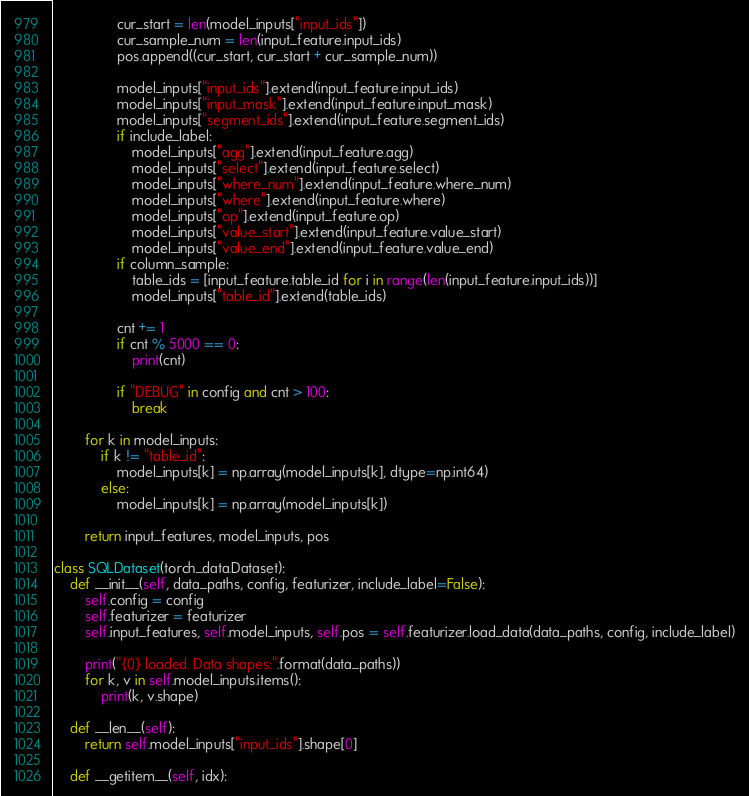Convert code to text. <code><loc_0><loc_0><loc_500><loc_500><_Python_>
                cur_start = len(model_inputs["input_ids"])
                cur_sample_num = len(input_feature.input_ids)
                pos.append((cur_start, cur_start + cur_sample_num))

                model_inputs["input_ids"].extend(input_feature.input_ids)
                model_inputs["input_mask"].extend(input_feature.input_mask)
                model_inputs["segment_ids"].extend(input_feature.segment_ids)
                if include_label:
                    model_inputs["agg"].extend(input_feature.agg)
                    model_inputs["select"].extend(input_feature.select)
                    model_inputs["where_num"].extend(input_feature.where_num)
                    model_inputs["where"].extend(input_feature.where)
                    model_inputs["op"].extend(input_feature.op)
                    model_inputs["value_start"].extend(input_feature.value_start)
                    model_inputs["value_end"].extend(input_feature.value_end)
                if column_sample:
                    table_ids = [input_feature.table_id for i in range(len(input_feature.input_ids))]
                    model_inputs["table_id"].extend(table_ids)

                cnt += 1
                if cnt % 5000 == 0:
                    print(cnt)

                if "DEBUG" in config and cnt > 100:
                    break

        for k in model_inputs:
            if k != "table_id":
                model_inputs[k] = np.array(model_inputs[k], dtype=np.int64)
            else:
                model_inputs[k] = np.array(model_inputs[k])

        return input_features, model_inputs, pos
    
class SQLDataset(torch_data.Dataset):
    def __init__(self, data_paths, config, featurizer, include_label=False):
        self.config = config
        self.featurizer = featurizer
        self.input_features, self.model_inputs, self.pos = self.featurizer.load_data(data_paths, config, include_label)

        print("{0} loaded. Data shapes:".format(data_paths))
        for k, v in self.model_inputs.items():
            print(k, v.shape)

    def __len__(self):
        return self.model_inputs["input_ids"].shape[0]

    def __getitem__(self, idx):</code> 